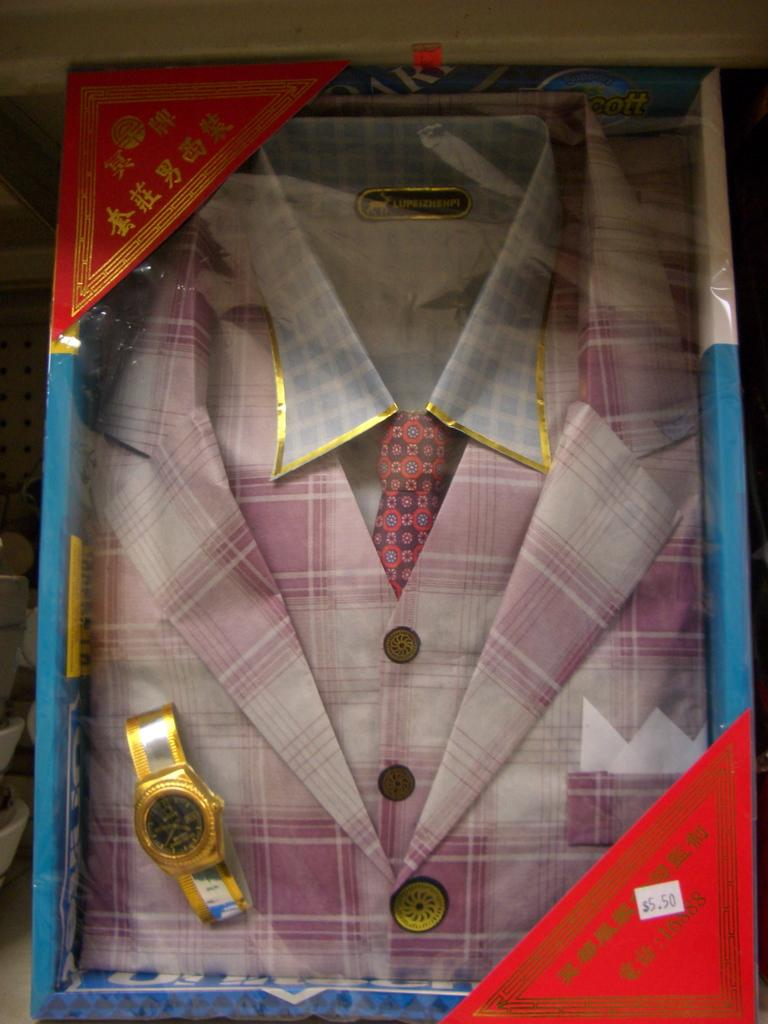What type of clothing is visible in the image? There is a pink suit with a tie in the image. What accessory is present in the image? There is a golden watch in the image. How are the items arranged in the image? The items are placed in a box. How many giants can be seen in the image? There are no giants present in the image. What type of terrain is visible in the image? The image does not show any terrain; it only features a pink suit, a tie, a golden watch, and a box. 